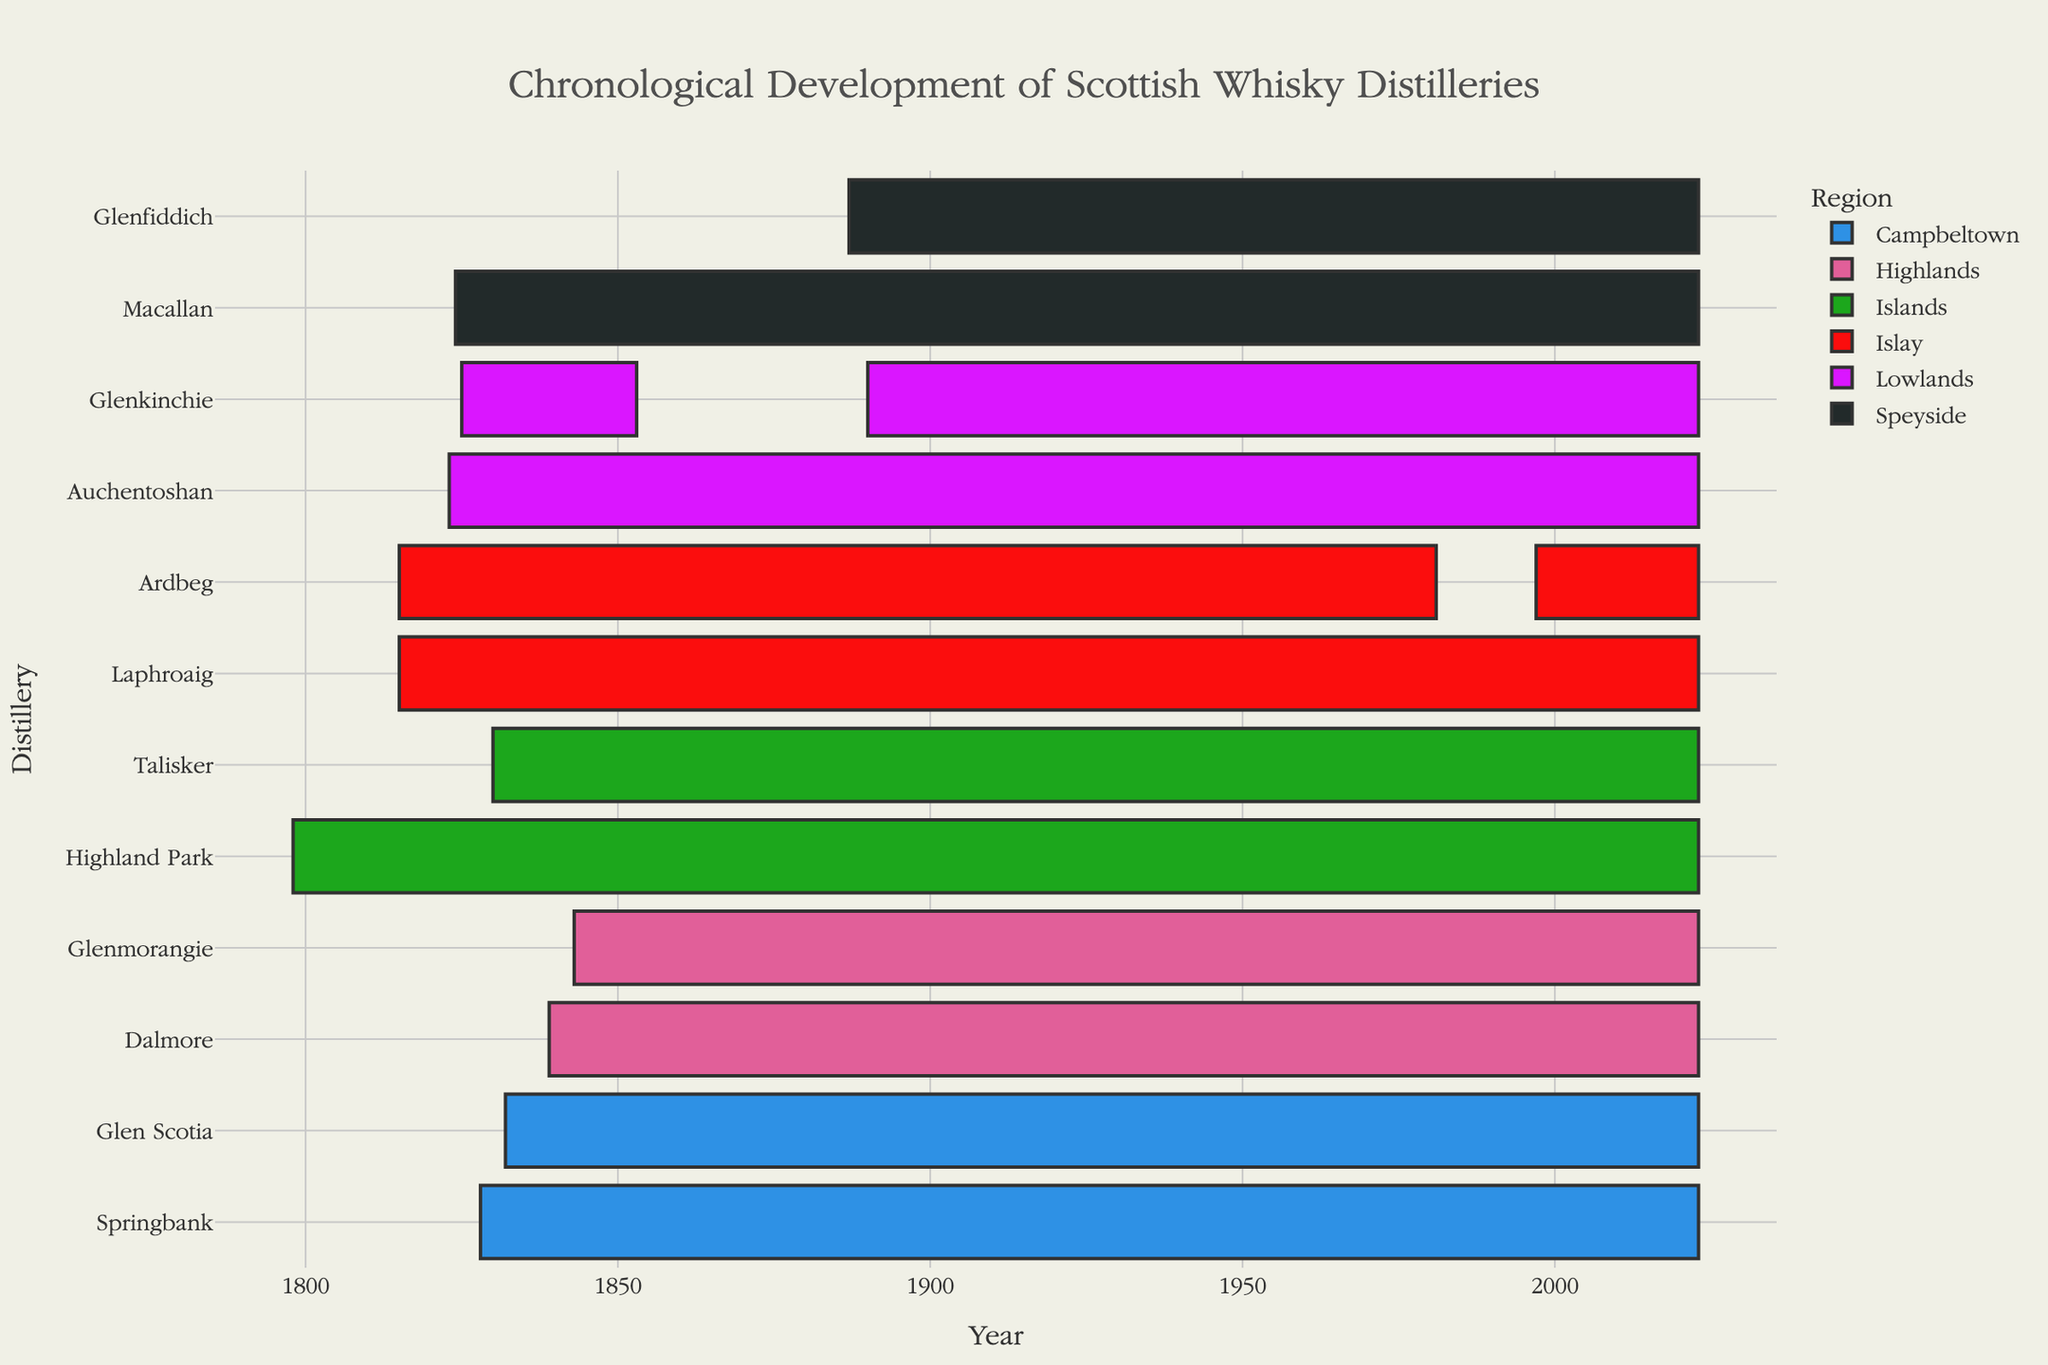What's the title of the chart? The title is typically displayed at the top of the chart, and it can be seen immediately upon looking at the figure.
Answer: Chronological Development of Scottish Whisky Distilleries Which distillery was established first? Look at the earliest date on the x-axis and find the corresponding distillery on the y-axis.
Answer: Highland Park Which distillery in the Lowlands region has had two distinct operational periods? Look for the distillery in the Lowlands region that appears twice in the timeline with a gap between the End year of the first period and the Start year of the second period.
Answer: Glenkinchie How many distilleries from the Islay region were established as of 2023? Count the unique entries for Islay region that have an End year of 2023.
Answer: 3 What is the longest operational distillery in the Highlands region? Compare the duration between the Start and End years of each distillery in the Highlands region and identify the longest one.
Answer: Glenmorangie Which region has the most distilleries represented in the chart? Count the number of distilleries in each region and compare.
Answer: Islay How long was the gap between the two operational periods of Ardbeg? Subtract the End year of the first operational period of Ardbeg from the Start year of its second operational period.
Answer: 16 years Which distillery has the shortest operational period? Identify the distillery with the smallest difference between the Start and End years.
Answer: Glenkinchie (first period) Are there any distilleries that have been continuously operational since their establishment? Find distilleries whose operational period has no gaps between the Start and End years and extends up to 2023.
Answer: Yes 